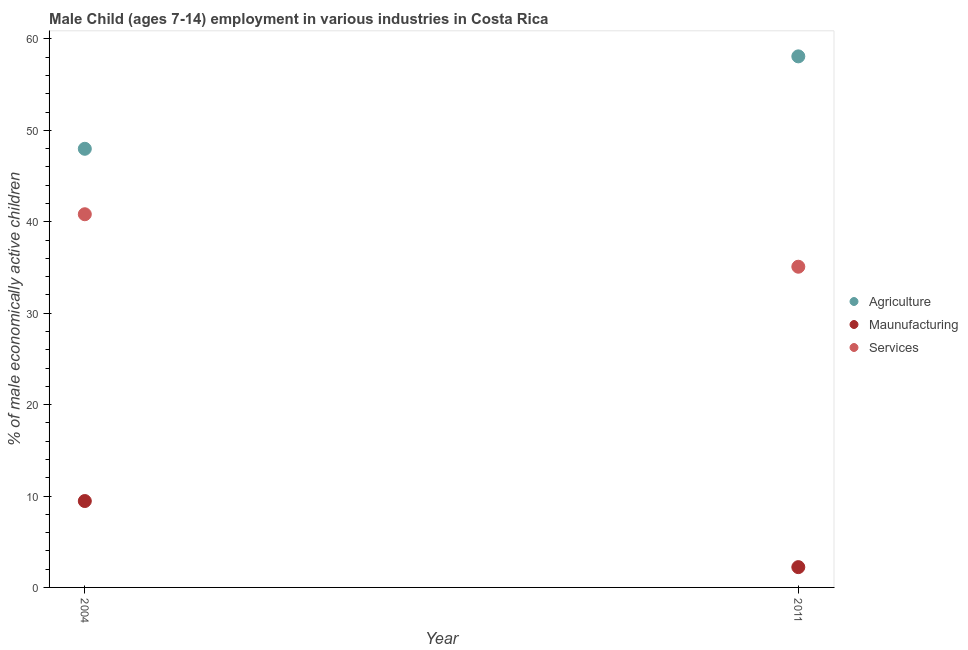How many different coloured dotlines are there?
Provide a succinct answer. 3. Is the number of dotlines equal to the number of legend labels?
Provide a succinct answer. Yes. What is the percentage of economically active children in agriculture in 2011?
Offer a very short reply. 58.09. Across all years, what is the maximum percentage of economically active children in agriculture?
Offer a terse response. 58.09. Across all years, what is the minimum percentage of economically active children in services?
Make the answer very short. 35.08. In which year was the percentage of economically active children in services maximum?
Offer a terse response. 2004. What is the total percentage of economically active children in services in the graph?
Your answer should be compact. 75.9. What is the difference between the percentage of economically active children in services in 2004 and that in 2011?
Ensure brevity in your answer.  5.74. What is the difference between the percentage of economically active children in manufacturing in 2011 and the percentage of economically active children in agriculture in 2004?
Keep it short and to the point. -45.76. What is the average percentage of economically active children in agriculture per year?
Provide a succinct answer. 53.03. In the year 2004, what is the difference between the percentage of economically active children in manufacturing and percentage of economically active children in services?
Ensure brevity in your answer.  -31.37. In how many years, is the percentage of economically active children in agriculture greater than 28 %?
Make the answer very short. 2. What is the ratio of the percentage of economically active children in services in 2004 to that in 2011?
Keep it short and to the point. 1.16. In how many years, is the percentage of economically active children in services greater than the average percentage of economically active children in services taken over all years?
Make the answer very short. 1. Is the percentage of economically active children in services strictly greater than the percentage of economically active children in agriculture over the years?
Your answer should be very brief. No. Is the percentage of economically active children in manufacturing strictly less than the percentage of economically active children in agriculture over the years?
Offer a terse response. Yes. Are the values on the major ticks of Y-axis written in scientific E-notation?
Your answer should be very brief. No. Does the graph contain any zero values?
Provide a short and direct response. No. Does the graph contain grids?
Provide a succinct answer. No. Where does the legend appear in the graph?
Your response must be concise. Center right. What is the title of the graph?
Give a very brief answer. Male Child (ages 7-14) employment in various industries in Costa Rica. Does "Ages 15-64" appear as one of the legend labels in the graph?
Your response must be concise. No. What is the label or title of the Y-axis?
Give a very brief answer. % of male economically active children. What is the % of male economically active children in Agriculture in 2004?
Ensure brevity in your answer.  47.98. What is the % of male economically active children of Maunufacturing in 2004?
Offer a terse response. 9.45. What is the % of male economically active children of Services in 2004?
Keep it short and to the point. 40.82. What is the % of male economically active children in Agriculture in 2011?
Your response must be concise. 58.09. What is the % of male economically active children of Maunufacturing in 2011?
Keep it short and to the point. 2.22. What is the % of male economically active children in Services in 2011?
Offer a terse response. 35.08. Across all years, what is the maximum % of male economically active children of Agriculture?
Your answer should be very brief. 58.09. Across all years, what is the maximum % of male economically active children in Maunufacturing?
Your answer should be very brief. 9.45. Across all years, what is the maximum % of male economically active children in Services?
Keep it short and to the point. 40.82. Across all years, what is the minimum % of male economically active children of Agriculture?
Make the answer very short. 47.98. Across all years, what is the minimum % of male economically active children in Maunufacturing?
Make the answer very short. 2.22. Across all years, what is the minimum % of male economically active children in Services?
Provide a succinct answer. 35.08. What is the total % of male economically active children in Agriculture in the graph?
Your response must be concise. 106.07. What is the total % of male economically active children of Maunufacturing in the graph?
Keep it short and to the point. 11.67. What is the total % of male economically active children in Services in the graph?
Provide a short and direct response. 75.9. What is the difference between the % of male economically active children of Agriculture in 2004 and that in 2011?
Offer a terse response. -10.11. What is the difference between the % of male economically active children in Maunufacturing in 2004 and that in 2011?
Keep it short and to the point. 7.23. What is the difference between the % of male economically active children in Services in 2004 and that in 2011?
Your answer should be very brief. 5.74. What is the difference between the % of male economically active children of Agriculture in 2004 and the % of male economically active children of Maunufacturing in 2011?
Your answer should be very brief. 45.76. What is the difference between the % of male economically active children in Maunufacturing in 2004 and the % of male economically active children in Services in 2011?
Provide a succinct answer. -25.63. What is the average % of male economically active children of Agriculture per year?
Provide a succinct answer. 53.03. What is the average % of male economically active children in Maunufacturing per year?
Your answer should be very brief. 5.83. What is the average % of male economically active children in Services per year?
Offer a very short reply. 37.95. In the year 2004, what is the difference between the % of male economically active children in Agriculture and % of male economically active children in Maunufacturing?
Your response must be concise. 38.53. In the year 2004, what is the difference between the % of male economically active children of Agriculture and % of male economically active children of Services?
Offer a terse response. 7.16. In the year 2004, what is the difference between the % of male economically active children of Maunufacturing and % of male economically active children of Services?
Offer a terse response. -31.37. In the year 2011, what is the difference between the % of male economically active children of Agriculture and % of male economically active children of Maunufacturing?
Provide a succinct answer. 55.87. In the year 2011, what is the difference between the % of male economically active children of Agriculture and % of male economically active children of Services?
Offer a very short reply. 23.01. In the year 2011, what is the difference between the % of male economically active children of Maunufacturing and % of male economically active children of Services?
Make the answer very short. -32.86. What is the ratio of the % of male economically active children of Agriculture in 2004 to that in 2011?
Provide a succinct answer. 0.83. What is the ratio of the % of male economically active children of Maunufacturing in 2004 to that in 2011?
Your response must be concise. 4.26. What is the ratio of the % of male economically active children of Services in 2004 to that in 2011?
Provide a succinct answer. 1.16. What is the difference between the highest and the second highest % of male economically active children in Agriculture?
Keep it short and to the point. 10.11. What is the difference between the highest and the second highest % of male economically active children in Maunufacturing?
Give a very brief answer. 7.23. What is the difference between the highest and the second highest % of male economically active children in Services?
Make the answer very short. 5.74. What is the difference between the highest and the lowest % of male economically active children of Agriculture?
Your answer should be very brief. 10.11. What is the difference between the highest and the lowest % of male economically active children of Maunufacturing?
Offer a terse response. 7.23. What is the difference between the highest and the lowest % of male economically active children of Services?
Your response must be concise. 5.74. 